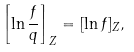Convert formula to latex. <formula><loc_0><loc_0><loc_500><loc_500>\left [ \ln \frac { f } { q } \right ] _ { Z } = [ \ln f ] _ { Z } ,</formula> 